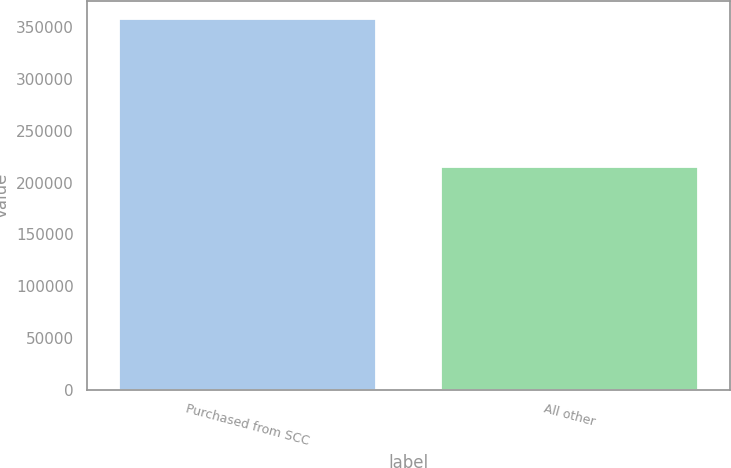Convert chart. <chart><loc_0><loc_0><loc_500><loc_500><bar_chart><fcel>Purchased from SCC<fcel>All other<nl><fcel>357814<fcel>215160<nl></chart> 